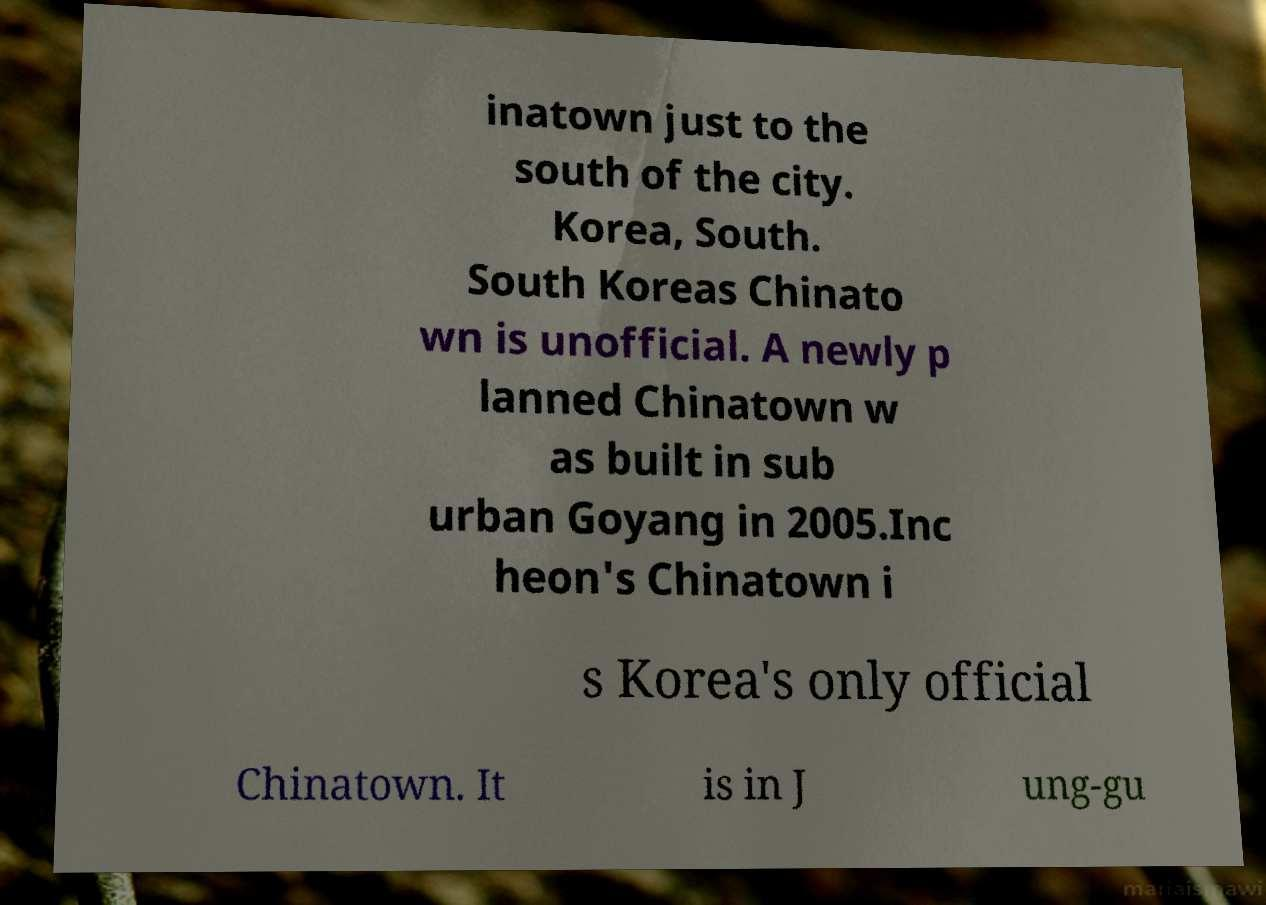There's text embedded in this image that I need extracted. Can you transcribe it verbatim? inatown just to the south of the city. Korea, South. South Koreas Chinato wn is unofficial. A newly p lanned Chinatown w as built in sub urban Goyang in 2005.Inc heon's Chinatown i s Korea's only official Chinatown. It is in J ung-gu 